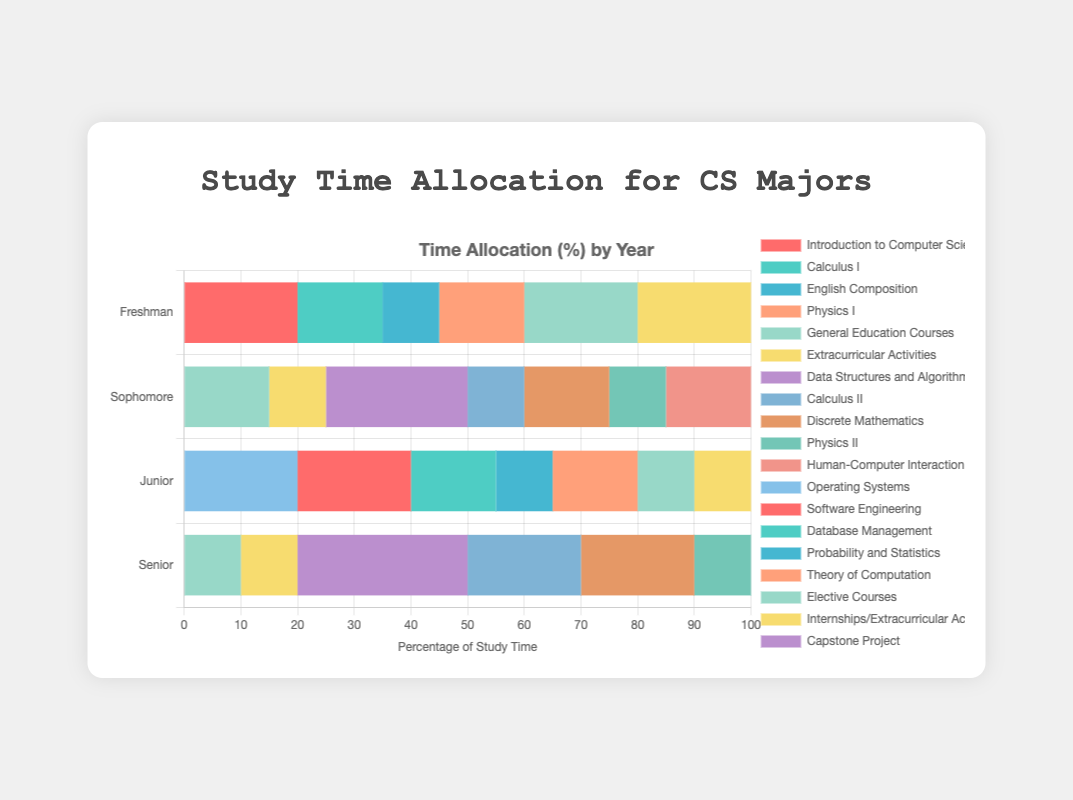What subject do Freshmen spend the most study time on? Look at the bar representing Freshmen and identify the subject with the longest segment.
Answer: Introduction to Computer Science Which year devotes the highest percentage of time to extracurricular activities? Compare the lengths of the "Extracurricular Activities" segments for all years. Freshmen have the longest segment.
Answer: Freshman How much total study time do Sophomores spend on math-related courses? Sum the percentages for "Calculus II" and "Discrete Mathematics" in the Sophomore bar. That adds up to 10 + 15 = 25.
Answer: 25 Which category has the same study time allocation in both Junior and Senior years? Compare the lengths of segments for each subject in Junior and Senior years and find which one matches exactly. "Elective Courses" and "Internships/Extracurricular Activities" both match at 10%.
Answer: Elective Courses, Internships/Extracurricular Activities What is the total percentage of study time spent on Computer Science-specific courses during the Senior year? Add the percentages for "Capstone Project," "Machine Learning," and "Advanced Algorithms" in the Senior bar. That adds up to 30 + 20 + 20 = 70.
Answer: 70 Do Juniors or Seniors spend more time on internships and extracurricular activities? Compare the segments for "Internships/Extracurricular Activities" in Junior and Senior years. Both are equal at 10%.
Answer: Equal What's the difference in study time spent on General Education Courses between Freshmen and Sophomores? Subtract the time spent by Sophomores (15) from the time spent by Freshmen (20). The difference is 20 - 15 = 5.
Answer: 5 Does any year not spend any time on Physics courses? Check each year's bar to see if there is a segment for Physics I or Physics II. Senior year has no segment for Physics courses.
Answer: Senior What percentage of study time is allocated to Software Engineering for Juniors? Look at the Junior year bar and identify the segment for "Software Engineering"; it's 20%.
Answer: 20 Which year has the most diverse allocation of study time across different subjects? Compare the visual distribution of segments across all years. Sophomore year has the largest number of different subjects, indicating a broader allocation.
Answer: Sophomore 